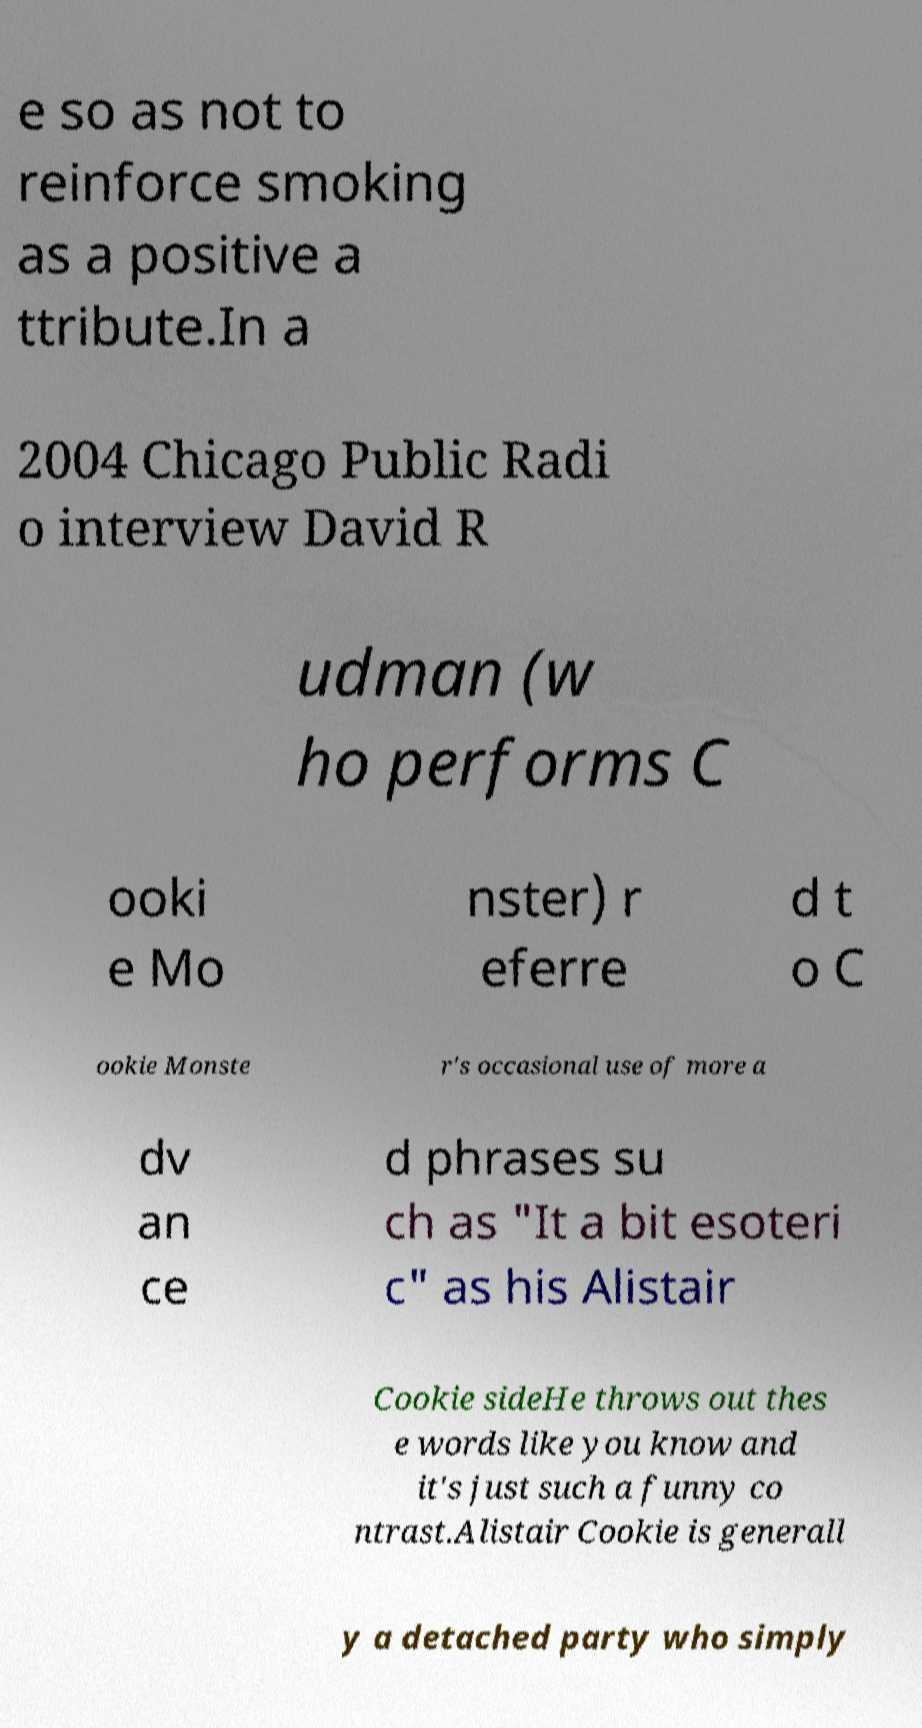What messages or text are displayed in this image? I need them in a readable, typed format. e so as not to reinforce smoking as a positive a ttribute.In a 2004 Chicago Public Radi o interview David R udman (w ho performs C ooki e Mo nster) r eferre d t o C ookie Monste r's occasional use of more a dv an ce d phrases su ch as "It a bit esoteri c" as his Alistair Cookie sideHe throws out thes e words like you know and it's just such a funny co ntrast.Alistair Cookie is generall y a detached party who simply 